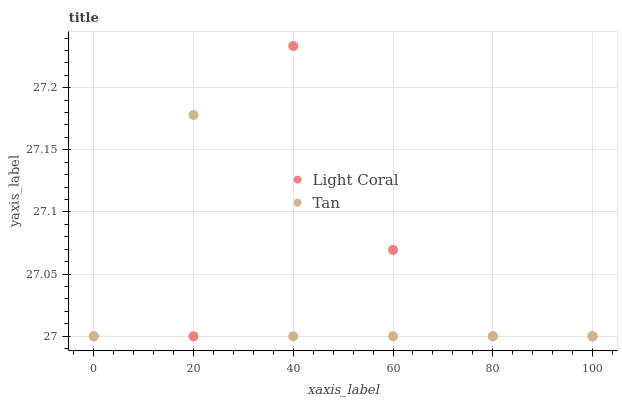Does Tan have the minimum area under the curve?
Answer yes or no. Yes. Does Light Coral have the maximum area under the curve?
Answer yes or no. Yes. Does Tan have the maximum area under the curve?
Answer yes or no. No. Is Tan the smoothest?
Answer yes or no. Yes. Is Light Coral the roughest?
Answer yes or no. Yes. Is Tan the roughest?
Answer yes or no. No. Does Light Coral have the lowest value?
Answer yes or no. Yes. Does Light Coral have the highest value?
Answer yes or no. Yes. Does Tan have the highest value?
Answer yes or no. No. Does Tan intersect Light Coral?
Answer yes or no. Yes. Is Tan less than Light Coral?
Answer yes or no. No. Is Tan greater than Light Coral?
Answer yes or no. No. 